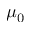Convert formula to latex. <formula><loc_0><loc_0><loc_500><loc_500>\mu _ { 0 }</formula> 